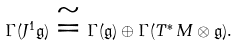Convert formula to latex. <formula><loc_0><loc_0><loc_500><loc_500>\Gamma ( J ^ { 1 } { \mathfrak g } ) \cong \Gamma ( { \mathfrak g } ) \oplus \Gamma ( T ^ { * } \, M \otimes { \mathfrak g } ) .</formula> 